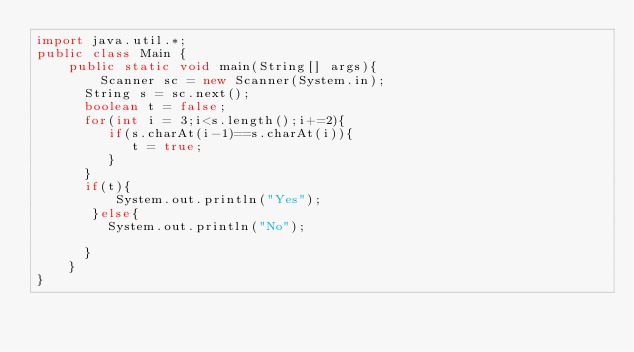Convert code to text. <code><loc_0><loc_0><loc_500><loc_500><_Java_>import java.util.*;
public class Main {
	public static void main(String[] args){
		Scanner sc = new Scanner(System.in);
      String s = sc.next();
      boolean t = false;
      for(int i = 3;i<s.length();i+=2){
         if(s.charAt(i-1)==s.charAt(i)){
            t = true;
         }
      }
      if(t){
          System.out.println("Yes");
       }else{
         System.out.println("No");
         
      }
	}
}</code> 